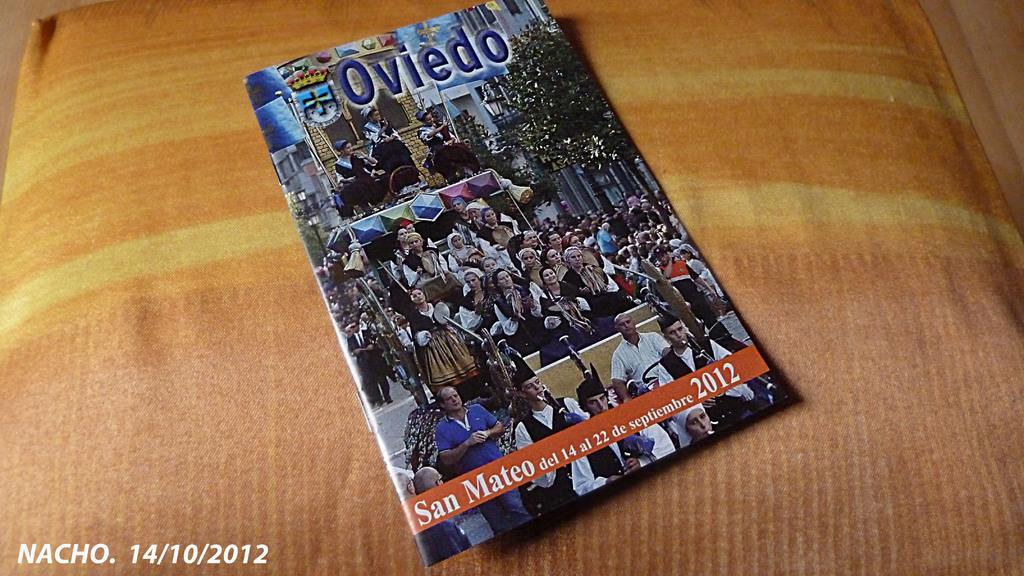<image>
Share a concise interpretation of the image provided. A 2012 issue of the magazine Oviedo is displayed on a cushion. 